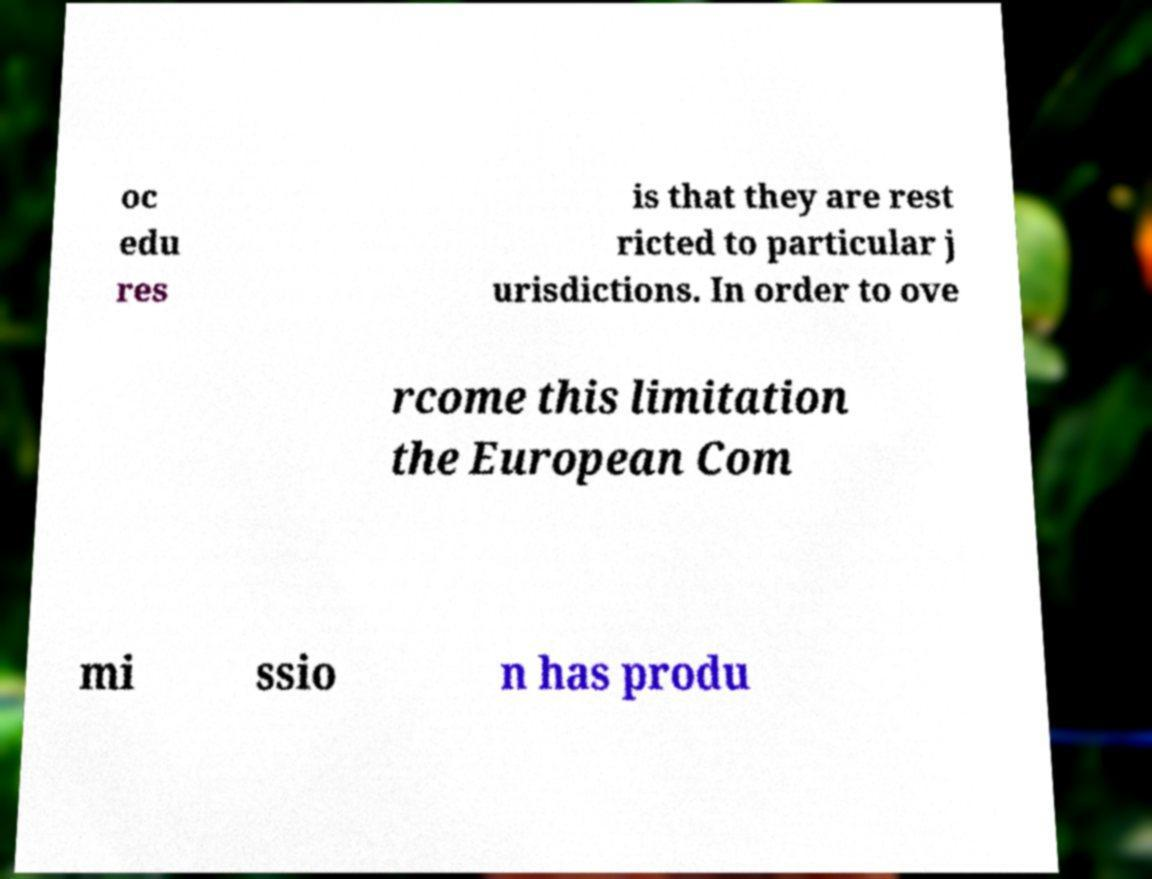Please read and relay the text visible in this image. What does it say? oc edu res is that they are rest ricted to particular j urisdictions. In order to ove rcome this limitation the European Com mi ssio n has produ 